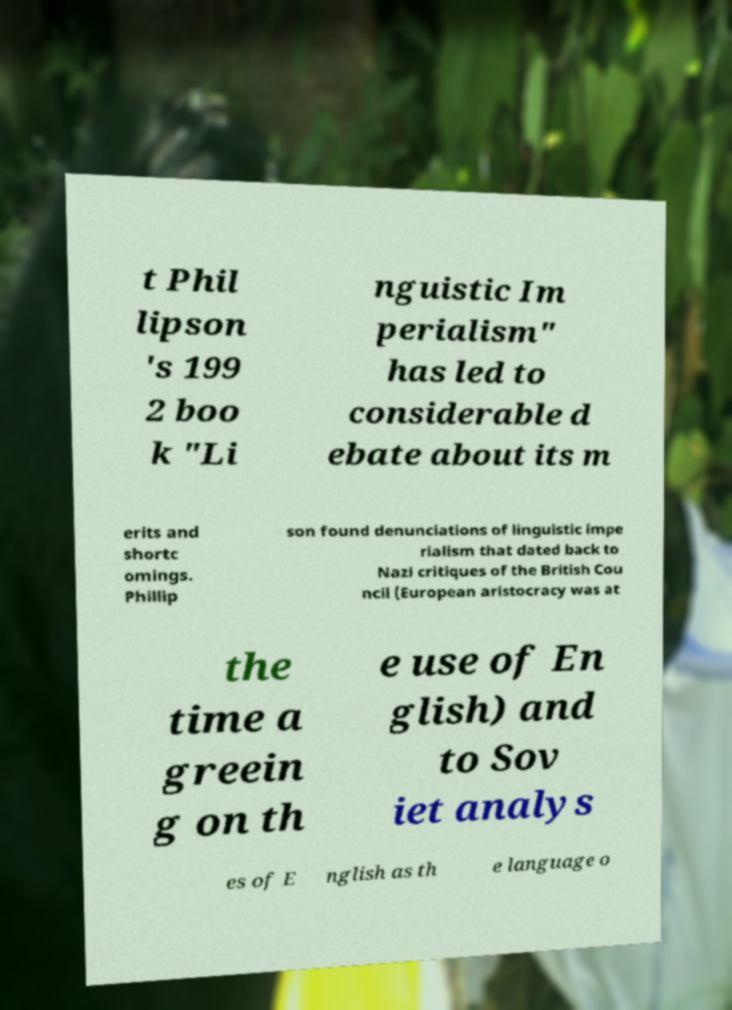For documentation purposes, I need the text within this image transcribed. Could you provide that? t Phil lipson 's 199 2 boo k "Li nguistic Im perialism" has led to considerable d ebate about its m erits and shortc omings. Phillip son found denunciations of linguistic impe rialism that dated back to Nazi critiques of the British Cou ncil (European aristocracy was at the time a greein g on th e use of En glish) and to Sov iet analys es of E nglish as th e language o 